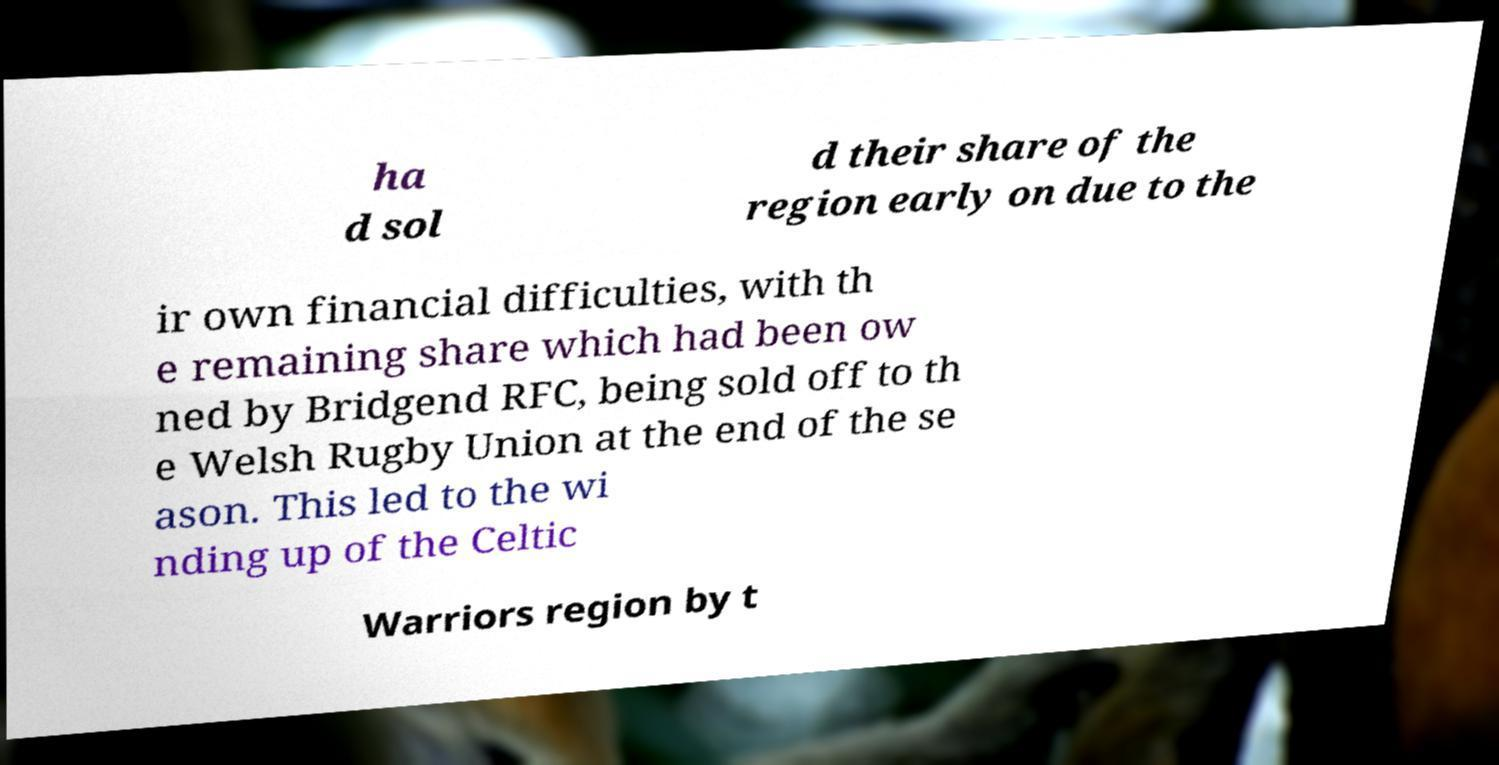Please read and relay the text visible in this image. What does it say? ha d sol d their share of the region early on due to the ir own financial difficulties, with th e remaining share which had been ow ned by Bridgend RFC, being sold off to th e Welsh Rugby Union at the end of the se ason. This led to the wi nding up of the Celtic Warriors region by t 